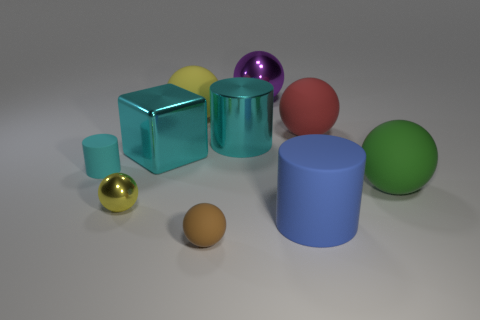There is a cube that is the same color as the metal cylinder; what material is it?
Your answer should be compact. Metal. There is a cyan metallic thing right of the yellow object that is behind the metallic sphere in front of the red sphere; what is its shape?
Offer a very short reply. Cylinder. Is the number of cubes that are in front of the yellow metallic object less than the number of brown spheres that are behind the tiny brown ball?
Make the answer very short. No. Are there any metallic spheres that have the same color as the metallic block?
Make the answer very short. No. Does the small brown sphere have the same material as the large object that is in front of the yellow metallic thing?
Your answer should be compact. Yes. There is a rubber cylinder on the left side of the large blue matte object; are there any yellow matte things that are in front of it?
Your response must be concise. No. What is the color of the matte ball that is both in front of the large block and left of the big metal cylinder?
Your response must be concise. Brown. What is the size of the brown sphere?
Your answer should be compact. Small. How many cyan rubber cylinders are the same size as the blue cylinder?
Your answer should be compact. 0. Are the sphere that is to the right of the red matte sphere and the large ball that is to the left of the large purple thing made of the same material?
Offer a very short reply. Yes. 